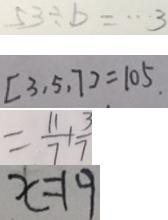<formula> <loc_0><loc_0><loc_500><loc_500>5 3 \div b = \cdots 3 
 [ 3 , 5 , 7 ] = 1 0 5 . 
 = \frac { 1 1 } { 7 } + \frac { 3 } { 7 } 
 x = 1 9</formula> 